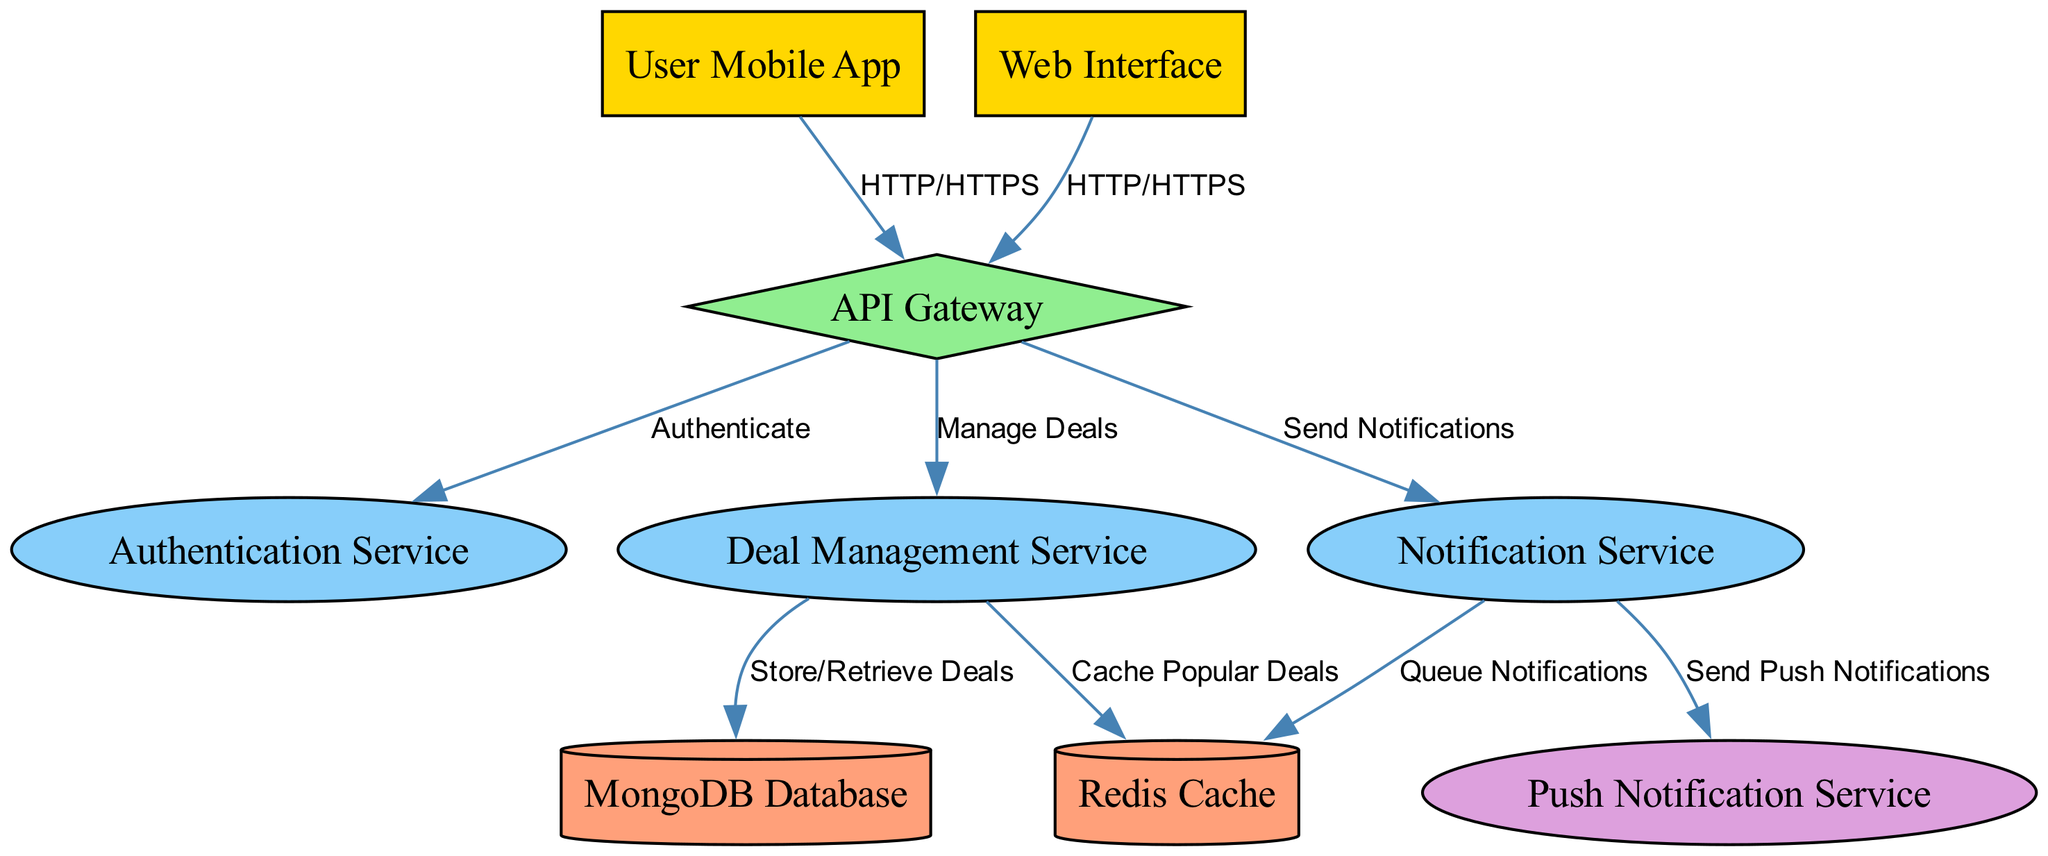What are the two main user interfaces in the diagram? The diagram displays two main user interfaces: the User Mobile App and the Web Interface. Both are directly connected to the API Gateway for HTTP/HTTPS communication.
Answer: User Mobile App, Web Interface How many total nodes are represented in the diagram? By counting the nodes listed in the provided data, we see there are a total of nine nodes, which include user_app, web_interface, api_gateway, auth_service, deal_service, notification_service, database, redis, and push_service.
Answer: Nine Which service is responsible for sending push notifications? The Push Notification Service is indicated in the diagram as the component responsible for sending push notifications. It is linked to the Notification Service, which uses it to communicate notifications effectively.
Answer: Push Notification Service What type of database is used in this architecture? The diagram specifies that a MongoDB Database is utilized in this architecture, specifically for storing and retrieving deals managed by the Deal Management Service.
Answer: MongoDB Database What is the relationship between the Cloud and the Authentication Service? The API Gateway connects to the Authentication Service, facilitating the process of user authentication for both the User Mobile App and the Web Interface. The connection is labeled as "Authenticate" in the diagram.
Answer: Authenticate Which service caches popular deals? The Redis Cache is responsible for caching popular deals as indicated by the connection from the Deal Management Service to the Redis node in the diagram for efficient data retrieval.
Answer: Redis Cache Which two services are connected through notification management? The Notification Service connects directly to both the Push Notification Service (to send notifications) and the Redis Cache (to queue notifications), demonstrating the management of notification processes.
Answer: Notification Service, Push Notification Service How do users authenticate to the system? Users authenticate through the API Gateway, which communicates directly with the Authentication Service, confirming user credentials for access to the platform.
Answer: API Gateway Which components are involved in the management of deals? The Deal Management Service and the MongoDB Database work together in managing deals; the diagram shows a connection from the Deal Management Service to the MongoDB Database for storing and retrieving information about deals.
Answer: Deal Management Service, MongoDB Database 